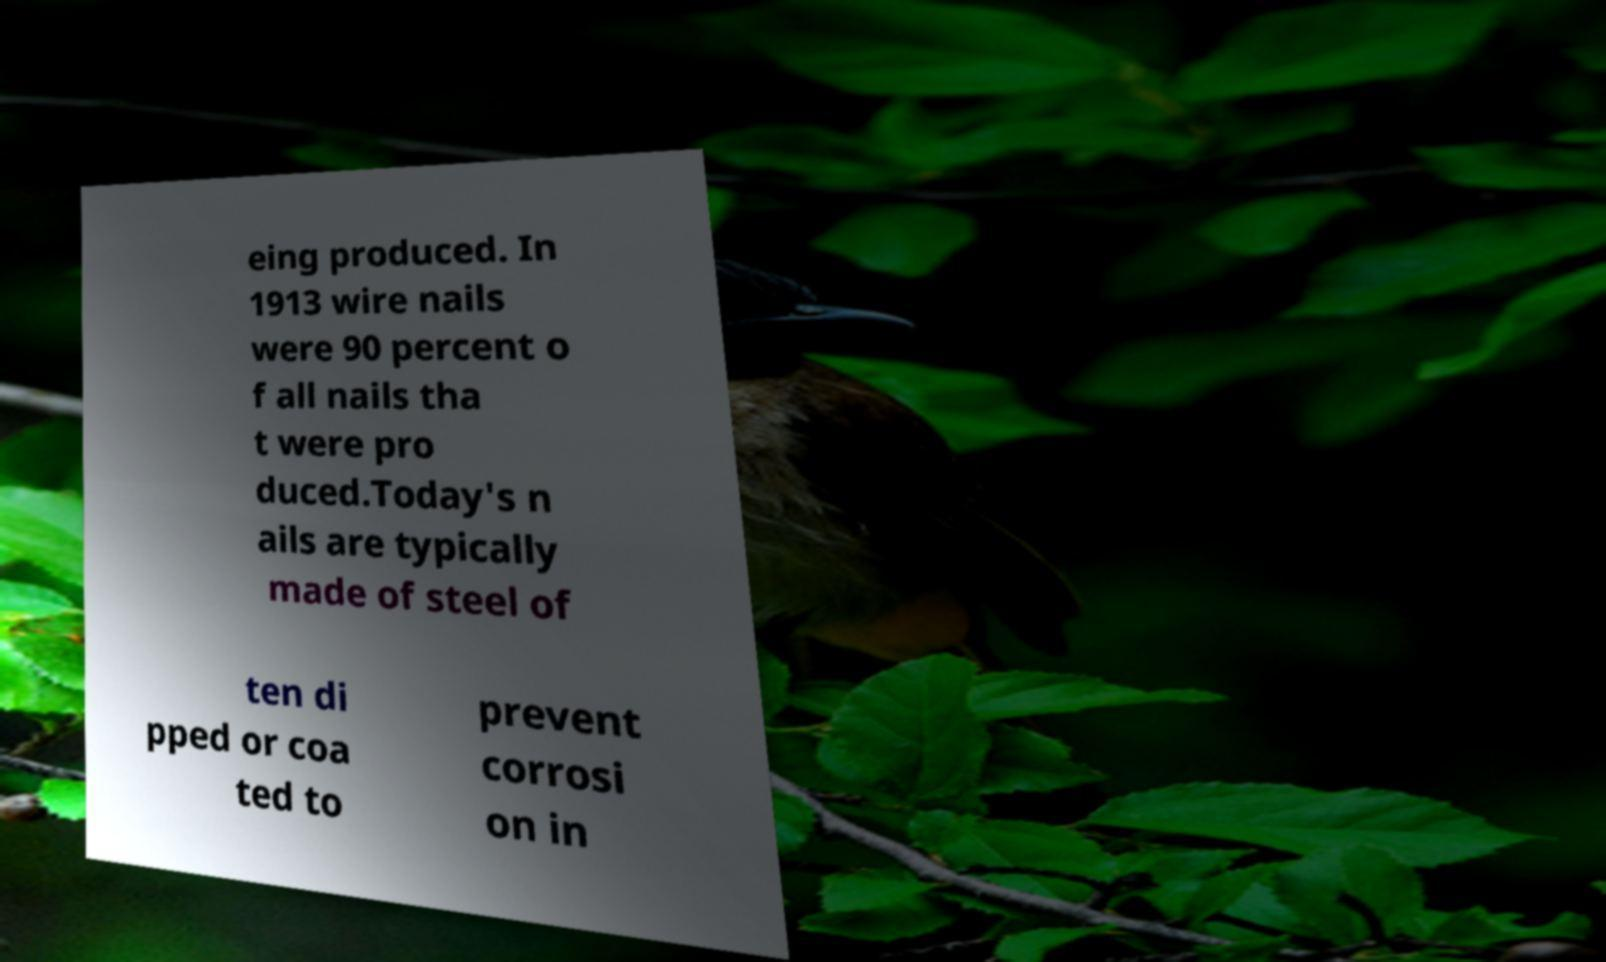Can you accurately transcribe the text from the provided image for me? eing produced. In 1913 wire nails were 90 percent o f all nails tha t were pro duced.Today's n ails are typically made of steel of ten di pped or coa ted to prevent corrosi on in 